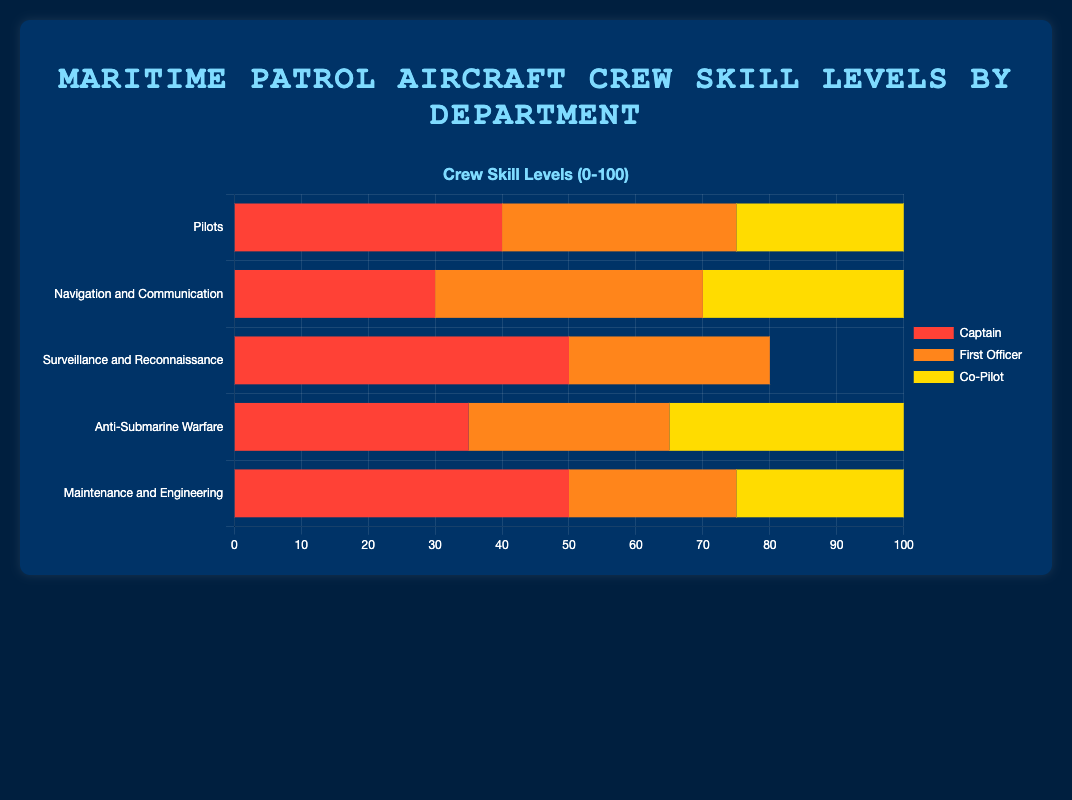Which department has the highest sum of skill levels? To find the department with the highest sum of skill levels, add the skill levels for each department and compare. The sums are: Pilots (100), Navigation and Communication (100), Surveillance and Reconnaissance (80), Anti-Submarine Warfare (100), Maintenance and Engineering (100). Therefore, Pilots, Navigation and Communication, Anti-Submarine Warfare, and Maintenance and Engineering all have the highest sum of 100.
Answer: Pilots, Navigation and Communication, Anti-Submarine Warfare, Maintenance and Engineering What is the average skill level of the 'Anti-Submarine Warfare' department? The skill levels for Anti-Submarine Warfare are Tactical Coordinator (35), Acoustic Operator (30), and Non-Acoustic Operator (35). The average is calculated as (35 + 30 + 35) / 3 = 100 / 3 ≈ 33.33.
Answer: 33.33 Which crew member role has the highest skill level in the 'Surveillance and Reconnaissance' department? The skill levels for Surveillance and Reconnaissance are Sensor Operator (50) and Mission Specialist (30). Comparing the two values, Sensor Operator has the highest skill level.
Answer: Sensor Operator Compare the total skill levels of 'Pilots' and 'Maintenance and Engineering'. Which department has a higher total? Summing the skill levels for Pilots (Captain: 40, First Officer: 35, Co-Pilot: 25) gives 40 + 35 + 25 = 100. Summing the skill levels for Maintenance and Engineering (Flight Engineer: 50, Mechanic: 25, Avionics Technician: 25) gives 50 + 25 + 25 = 100. Both departments have the same total skill level.
Answer: Equal Which color represents 'Electronic Warfare Officer' in the chart? The color associated with 'Electronic Warfare Officer' can be identified from the legend. In this case, it is the fourth dataset listed and thus the corresponding color in the chart legend.
Answer: Green What is the difference between the skill levels of the highest and lowest crew member roles in 'Navigation and Communication'? The skill levels in Navigation and Communication are Navigator (30), Radio Operator (40), and Electronic Warfare Officer (30). The highest level is 40 (Radio Operator) and the lowest is 30 (Navigator and Electronic Warfare Officer). The difference is 40 - 30 = 10.
Answer: 10 Which department has the longest bar in the chart? The length of the bar correlates with the sum of skill levels. Since Pilots, Navigation and Communication, Anti-Submarine Warfare, and Maintenance and Engineering all have the same highest sum of 100, they each have the longest bars.
Answer: Pilots, Navigation and Communication, Anti-Submarine Warfare, Maintenance and Engineering Compare the skill levels of 'First Officer' and 'Mechanic'. Which role has a higher skill level? First Officer has a skill level of 35, while Mechanic has a skill level of 25. Comparing these values, First Officer has a higher skill level.
Answer: First Officer 